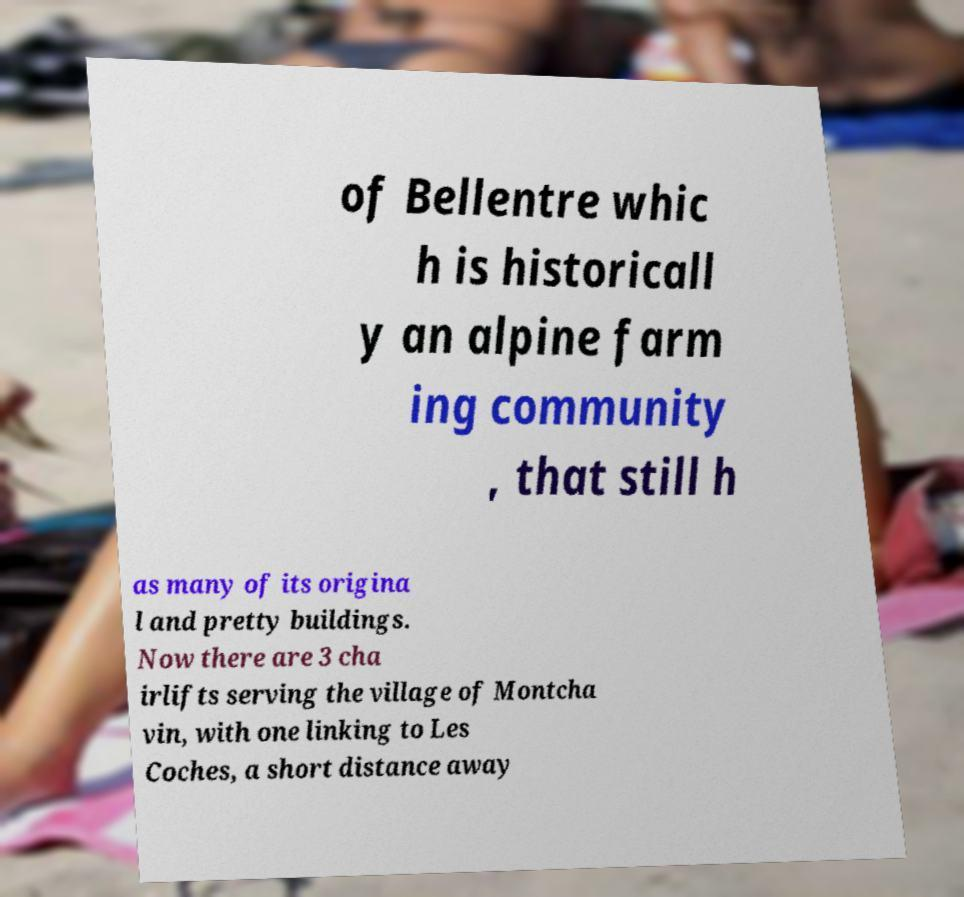Please identify and transcribe the text found in this image. of Bellentre whic h is historicall y an alpine farm ing community , that still h as many of its origina l and pretty buildings. Now there are 3 cha irlifts serving the village of Montcha vin, with one linking to Les Coches, a short distance away 